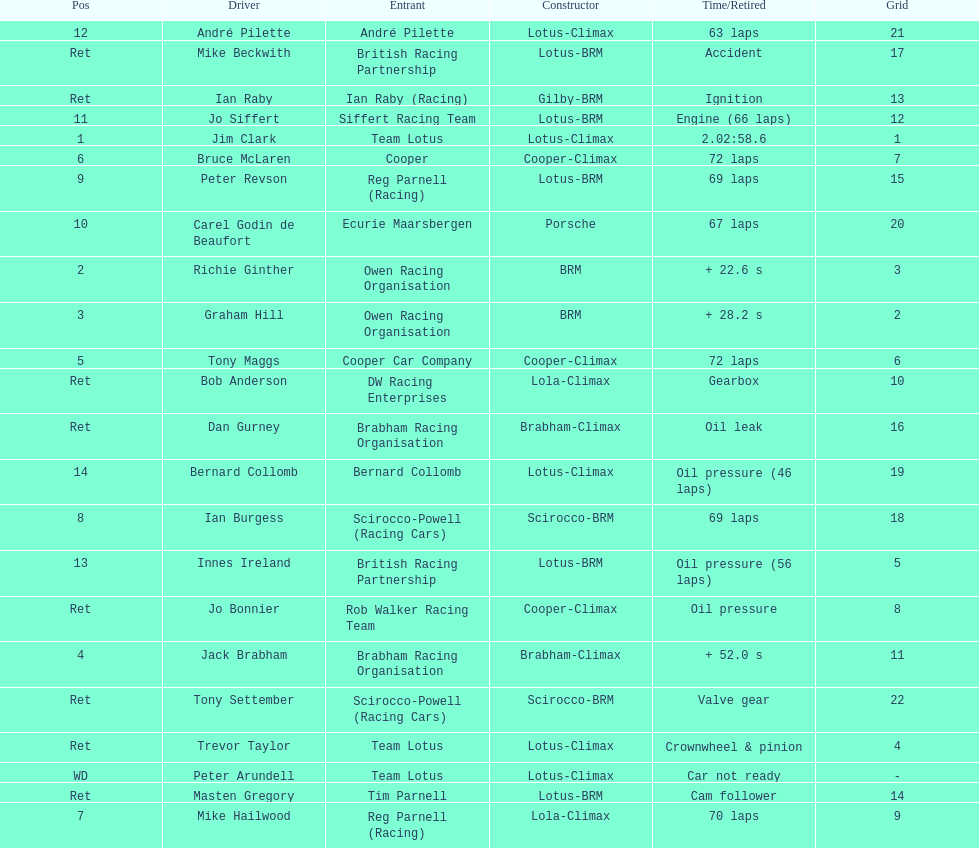What was the same problem that bernard collomb had as innes ireland? Oil pressure. 